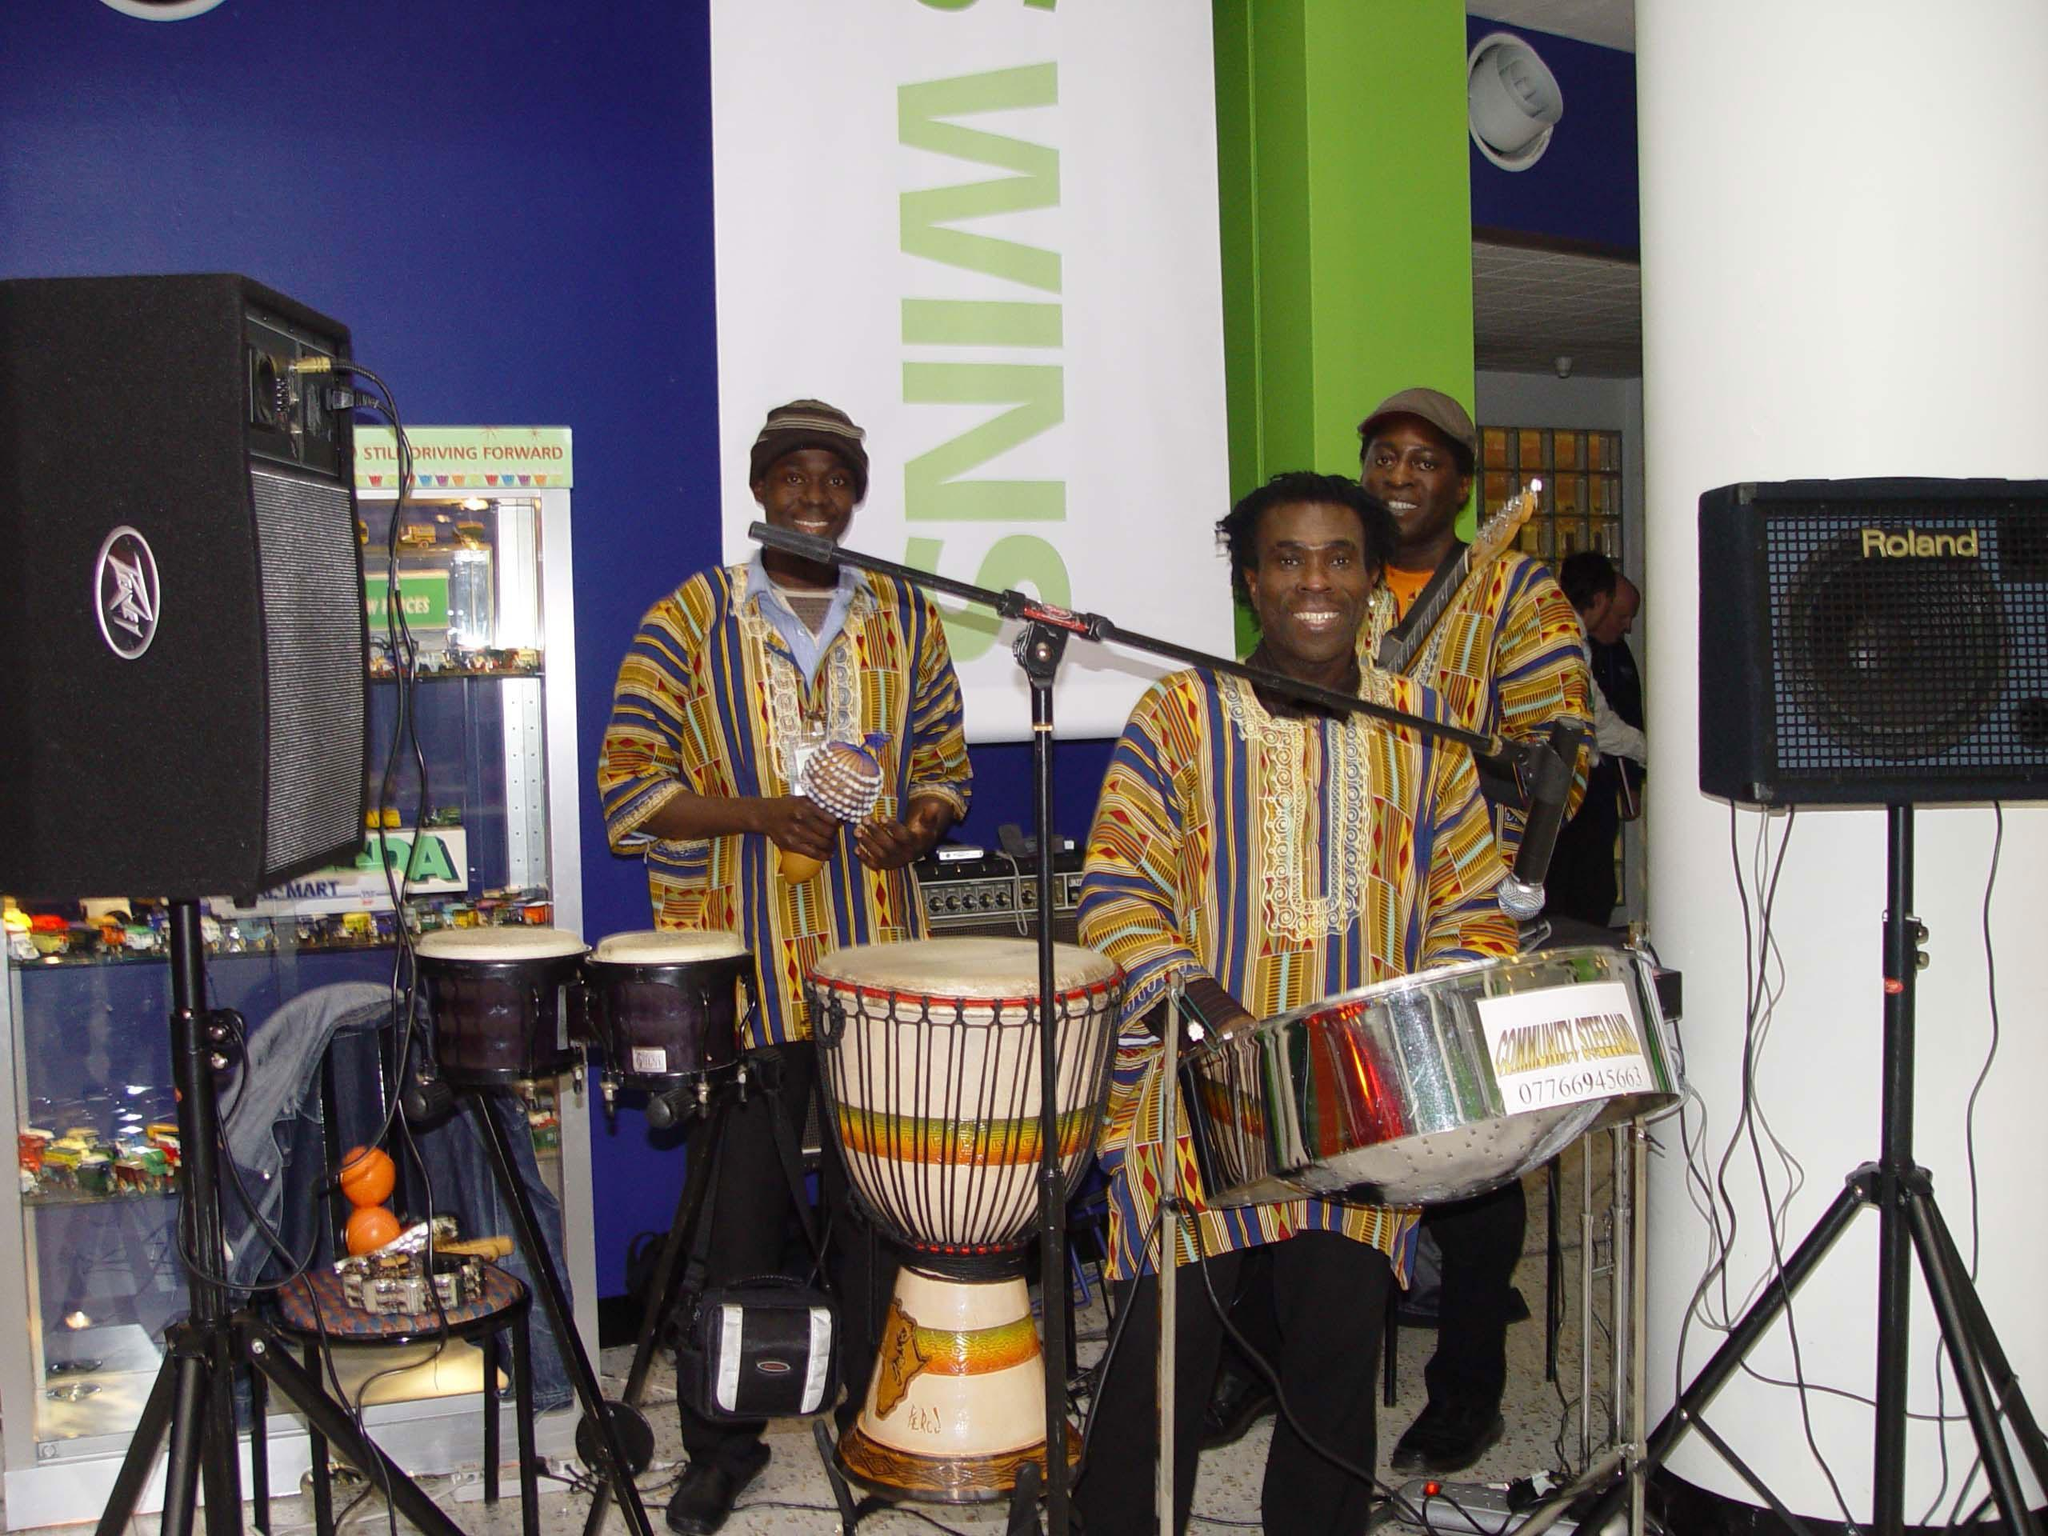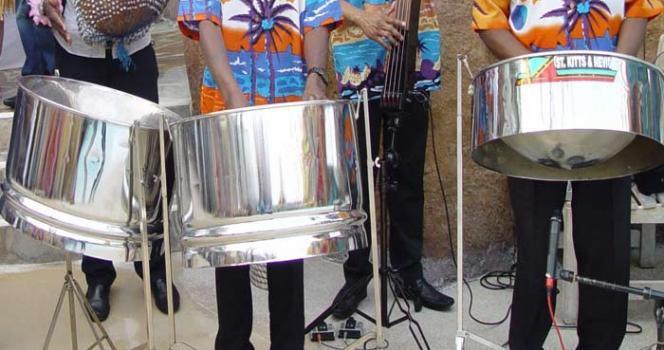The first image is the image on the left, the second image is the image on the right. Evaluate the accuracy of this statement regarding the images: "The left and right image contains seven drums.". Is it true? Answer yes or no. Yes. The first image is the image on the left, the second image is the image on the right. Evaluate the accuracy of this statement regarding the images: "The left image features only man in a hawaiian shirt who is playing a silver-colored drum.". Is it true? Answer yes or no. No. 